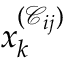<formula> <loc_0><loc_0><loc_500><loc_500>x _ { k } ^ { ( \mathcal { C } _ { i j } ) }</formula> 